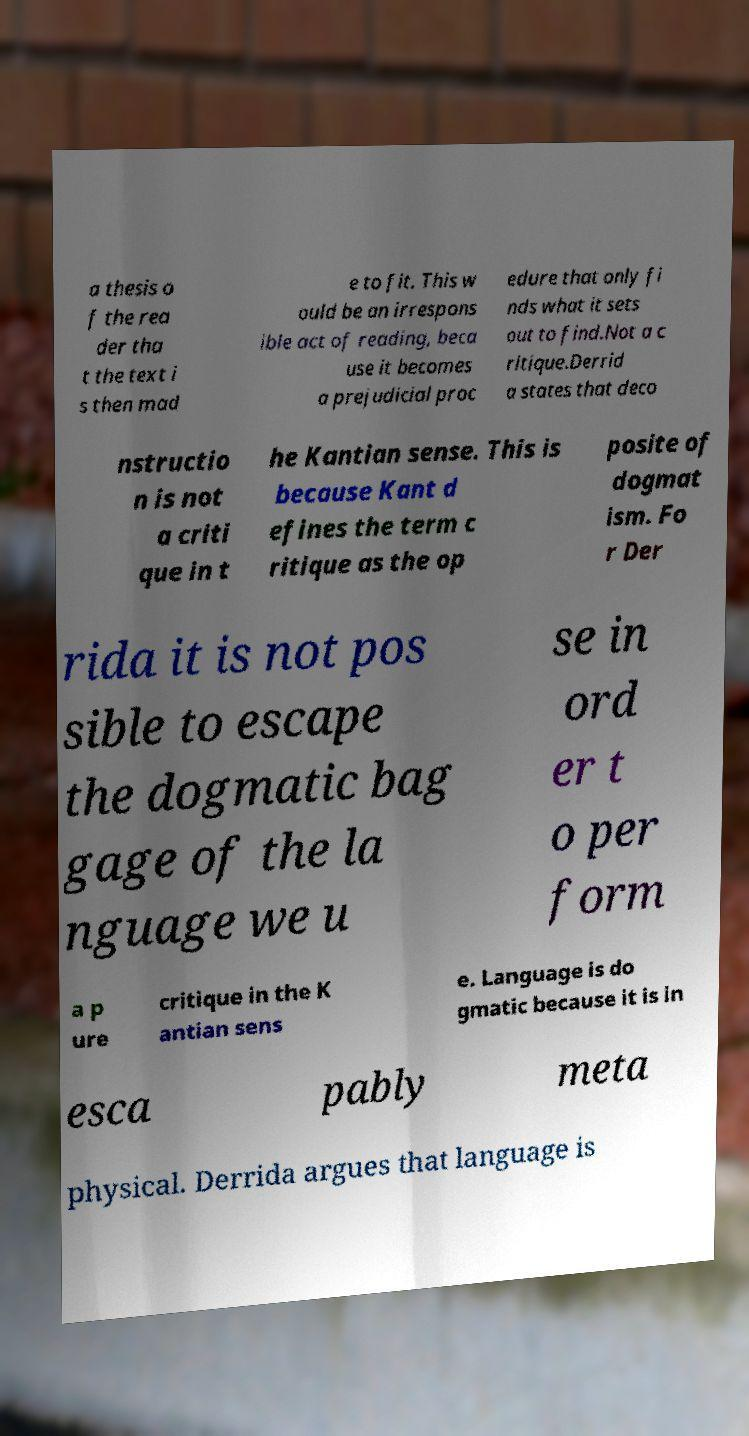There's text embedded in this image that I need extracted. Can you transcribe it verbatim? a thesis o f the rea der tha t the text i s then mad e to fit. This w ould be an irrespons ible act of reading, beca use it becomes a prejudicial proc edure that only fi nds what it sets out to find.Not a c ritique.Derrid a states that deco nstructio n is not a criti que in t he Kantian sense. This is because Kant d efines the term c ritique as the op posite of dogmat ism. Fo r Der rida it is not pos sible to escape the dogmatic bag gage of the la nguage we u se in ord er t o per form a p ure critique in the K antian sens e. Language is do gmatic because it is in esca pably meta physical. Derrida argues that language is 